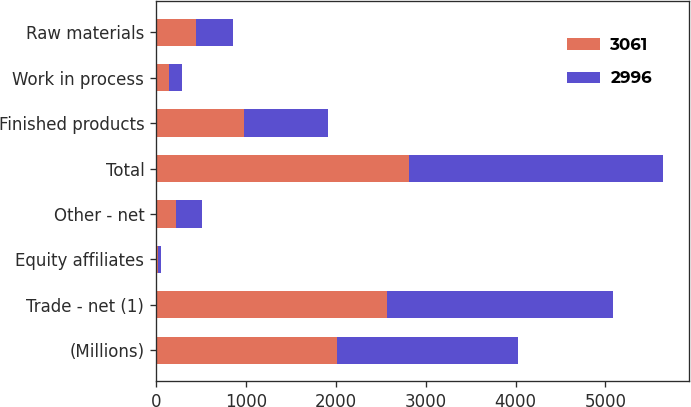<chart> <loc_0><loc_0><loc_500><loc_500><stacked_bar_chart><ecel><fcel>(Millions)<fcel>Trade - net (1)<fcel>Equity affiliates<fcel>Other - net<fcel>Total<fcel>Finished products<fcel>Work in process<fcel>Raw materials<nl><fcel>3061<fcel>2012<fcel>2568<fcel>22<fcel>223<fcel>2813<fcel>980<fcel>144<fcel>443<nl><fcel>2996<fcel>2011<fcel>2512<fcel>28<fcel>290<fcel>2830<fcel>935<fcel>144<fcel>414<nl></chart> 